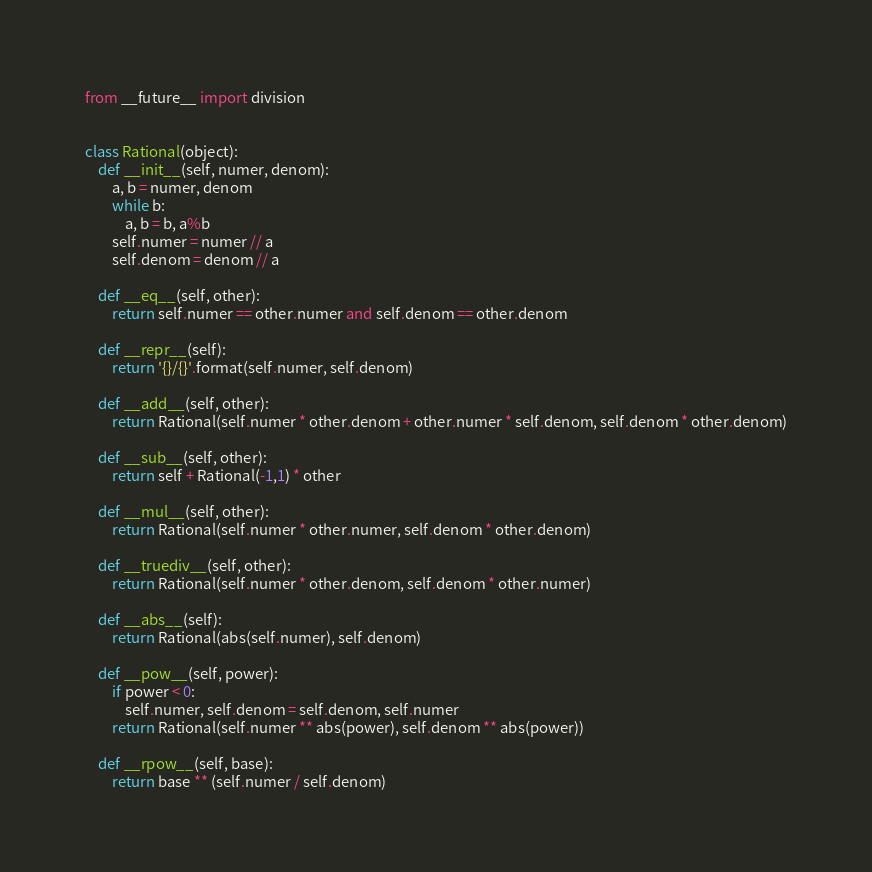Convert code to text. <code><loc_0><loc_0><loc_500><loc_500><_Python_>from __future__ import division


class Rational(object):
    def __init__(self, numer, denom):
        a, b = numer, denom
        while b:
            a, b = b, a%b
        self.numer = numer // a
        self.denom = denom // a

    def __eq__(self, other):
        return self.numer == other.numer and self.denom == other.denom

    def __repr__(self):
        return '{}/{}'.format(self.numer, self.denom)

    def __add__(self, other):
        return Rational(self.numer * other.denom + other.numer * self.denom, self.denom * other.denom)

    def __sub__(self, other):
        return self + Rational(-1,1) * other

    def __mul__(self, other):
        return Rational(self.numer * other.numer, self.denom * other.denom)

    def __truediv__(self, other):
        return Rational(self.numer * other.denom, self.denom * other.numer)

    def __abs__(self):
        return Rational(abs(self.numer), self.denom)

    def __pow__(self, power):
        if power < 0:
            self.numer, self.denom = self.denom, self.numer
        return Rational(self.numer ** abs(power), self.denom ** abs(power))

    def __rpow__(self, base):
        return base ** (self.numer / self.denom)
</code> 